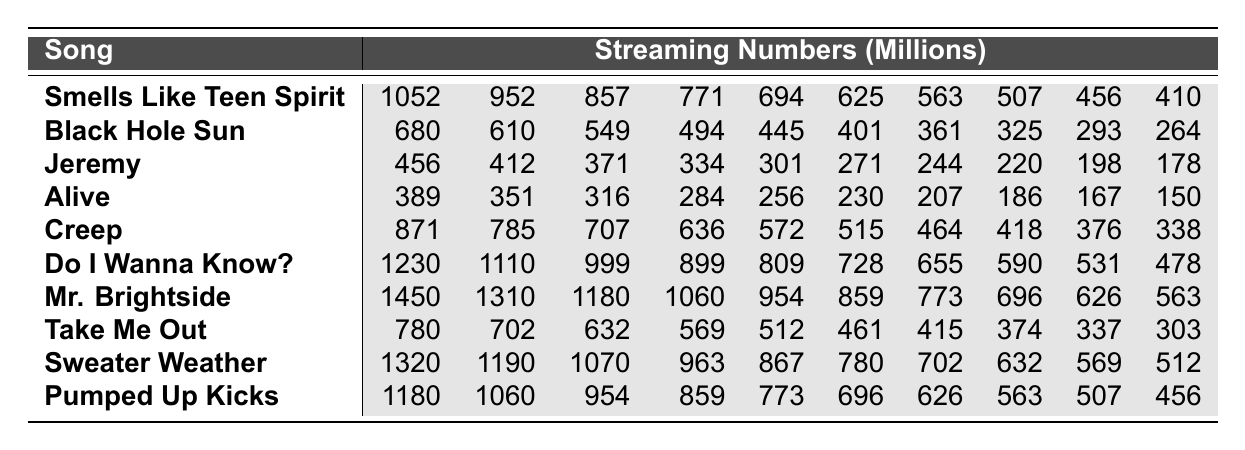What's the highest streaming number for "Smells Like Teen Spirit"? The table shows that the highest streaming number for "Smells Like Teen Spirit" is 1052 million.
Answer: 1052 million Which modern indie rock song has the lowest streaming number? By looking at the table, "Do I Wanna Know?" has the lowest streaming number of 478 million among the modern indie rock songs.
Answer: 478 million What's the average streaming number for "Mr. Brightside"? The streaming numbers for "Mr. Brightside" are 1450, 1310, 1180, 1060, 954, 859, 773, 696, 626, and 563. Adding these values gives 10627, and dividing by 10 yields an average of 1062.7 million.
Answer: 1062.7 million Is "Pumped Up Kicks" more popular than "Creep"? Comparing the highest streaming numbers, "Pumped Up Kicks" has 1180 million, while "Creep" has 871 million; therefore, "Pumped Up Kicks" is indeed more popular.
Answer: Yes What is the total streaming number for all listed classic grunge tracks? The streaming numbers for classic grunge tracks are: 1052 + 680 + 456 + 389 + 871 = 3434 million. Other songs are excluded as they belong to modern indie rock.
Answer: 3434 million What difference in streaming numbers exists between the highest classic grunge track and the highest modern indie rock song? The highest classic grunge track, "Smells Like Teen Spirit," has 1052 million, and the highest modern indie rock song, "Sweater Weather," has 1320 million. The difference is 1320 - 1052 = 268 million.
Answer: 268 million Which classic grunge track has the second highest streaming number? From the table, "Black Hole Sun" has the second highest streaming number at 680 million after "Smells Like Teen Spirit."
Answer: 680 million What's the median streaming number for "Take Me Out"? The streaming numbers for "Take Me Out" are 780, 702, 632, 569, 512, 461, 415, 374, 337, and 303. When arranged in order, the median (the average of the 5th and 6th values) is (512 + 461) / 2 = 486.5 million.
Answer: 486.5 million How many songs have streaming numbers exceeding 1 billion? Counting the numbers above 1000 million, we find four: "Smells Like Teen Spirit," "Do I Wanna Know?," "Mr. Brightside," and "Sweater Weather." Therefore, there are four songs exceeding 1 billion.
Answer: 4 Which song has a larger gap between its highest and lowest streaming numbers, "Creep" or "Do I Wanna Know?" "Creep" has a range from 871 to 338 million, which is a gap of 533 million. "Do I Wanna Know?" has a range from 1230 to 478 million, making a gap of 752 million. The larger gap is with "Do I Wanna Know?".
Answer: "Do I Wanna Know?" 